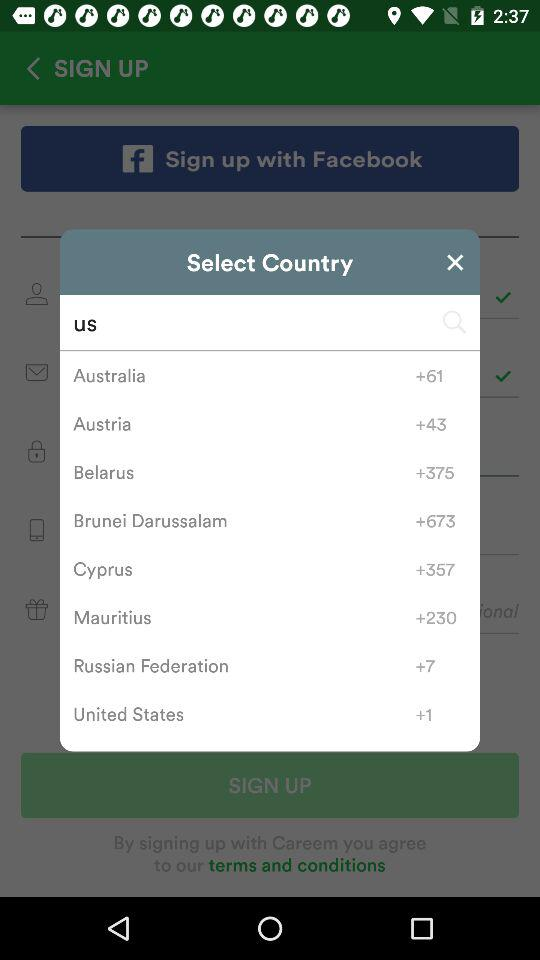Which country's code is +61? The country with the country code +61 is Australia. 